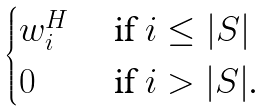Convert formula to latex. <formula><loc_0><loc_0><loc_500><loc_500>\begin{cases} w _ { i } ^ { H } & \text { if $i \leq |S|$} \\ 0 & \text { if $i > |S|$.} \end{cases}</formula> 